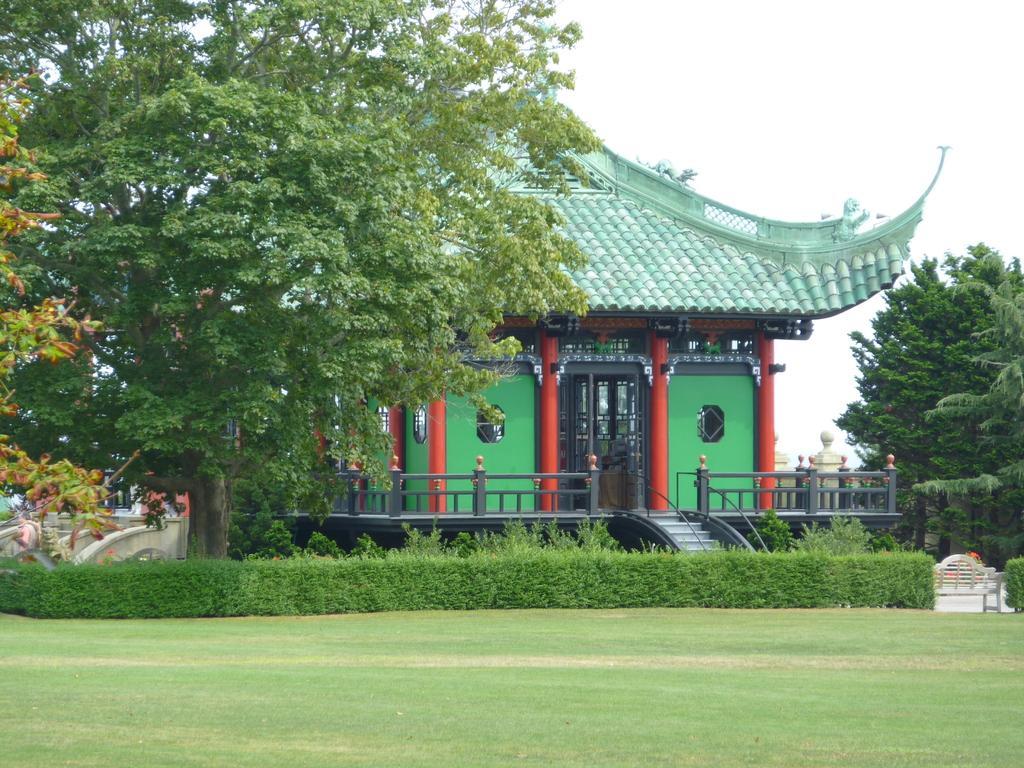In one or two sentences, can you explain what this image depicts? In this image in there's grass on the ground. In the center there are plants. In the background there are trees and there is a house and the sky is cloudy. 